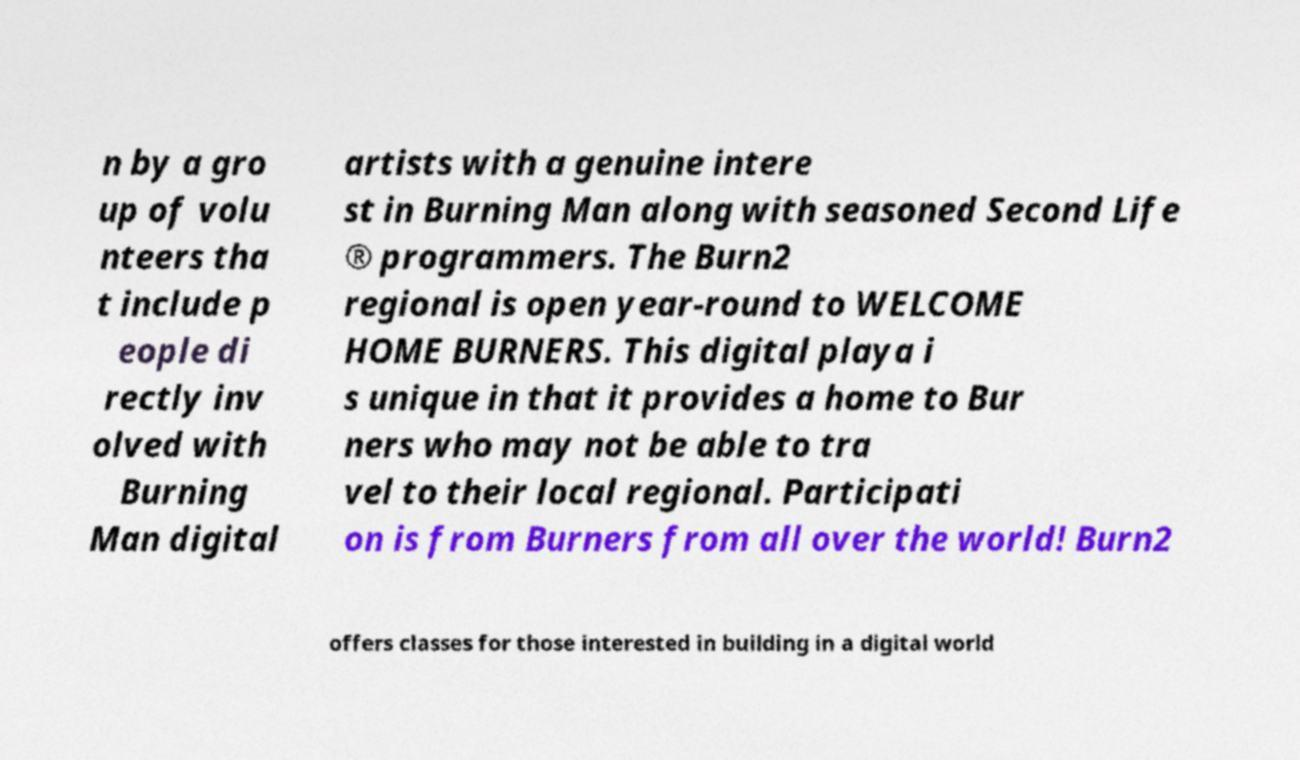There's text embedded in this image that I need extracted. Can you transcribe it verbatim? n by a gro up of volu nteers tha t include p eople di rectly inv olved with Burning Man digital artists with a genuine intere st in Burning Man along with seasoned Second Life ® programmers. The Burn2 regional is open year-round to WELCOME HOME BURNERS. This digital playa i s unique in that it provides a home to Bur ners who may not be able to tra vel to their local regional. Participati on is from Burners from all over the world! Burn2 offers classes for those interested in building in a digital world 